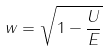Convert formula to latex. <formula><loc_0><loc_0><loc_500><loc_500>w = \sqrt { 1 - \frac { U } { E } }</formula> 